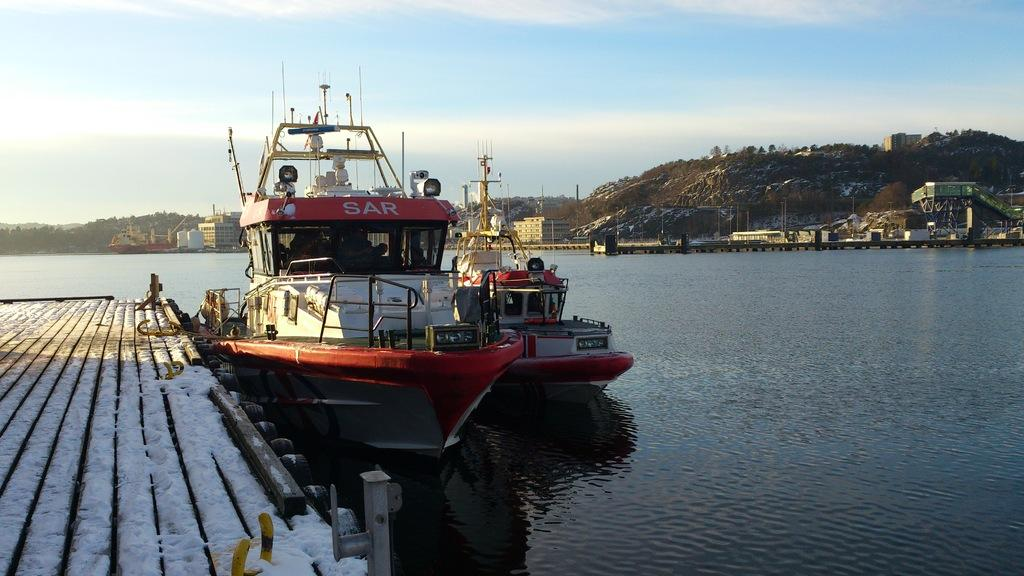<image>
Present a compact description of the photo's key features. A red and white boat with eh word sar on the red top side of it. 